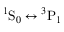<formula> <loc_0><loc_0><loc_500><loc_500>{ } ^ { 1 } S _ { 0 } ^ { 3 } P _ { 1 }</formula> 